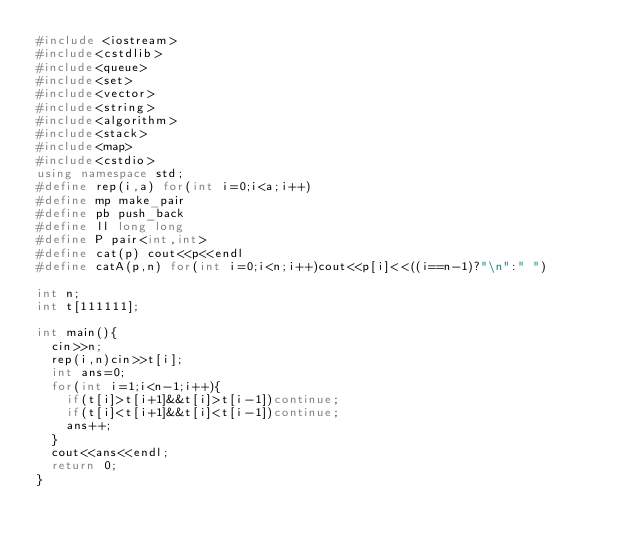<code> <loc_0><loc_0><loc_500><loc_500><_C++_>#include <iostream>
#include<cstdlib>
#include<queue>
#include<set>
#include<vector>
#include<string>
#include<algorithm>
#include<stack>
#include<map>
#include<cstdio>
using namespace std;
#define rep(i,a) for(int i=0;i<a;i++)
#define mp make_pair
#define pb push_back
#define ll long long
#define P pair<int,int>
#define cat(p) cout<<p<<endl
#define catA(p,n) for(int i=0;i<n;i++)cout<<p[i]<<((i==n-1)?"\n":" ")

int n;
int t[111111];

int main(){
  cin>>n;
  rep(i,n)cin>>t[i];
  int ans=0;
  for(int i=1;i<n-1;i++){
    if(t[i]>t[i+1]&&t[i]>t[i-1])continue;
    if(t[i]<t[i+1]&&t[i]<t[i-1])continue;
    ans++;
  }
  cout<<ans<<endl;
  return 0;
}
</code> 